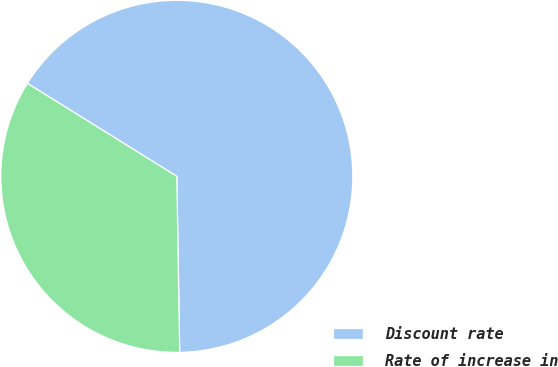Convert chart to OTSL. <chart><loc_0><loc_0><loc_500><loc_500><pie_chart><fcel>Discount rate<fcel>Rate of increase in<nl><fcel>65.88%<fcel>34.12%<nl></chart> 